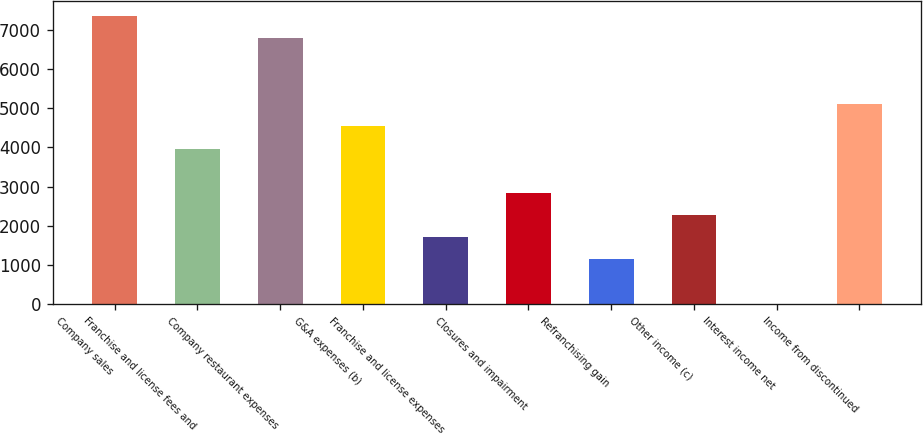Convert chart to OTSL. <chart><loc_0><loc_0><loc_500><loc_500><bar_chart><fcel>Company sales<fcel>Franchise and license fees and<fcel>Company restaurant expenses<fcel>G&A expenses (b)<fcel>Franchise and license expenses<fcel>Closures and impairment<fcel>Refranchising gain<fcel>Other income (c)<fcel>Interest income net<fcel>Income from discontinued<nl><fcel>7364.7<fcel>3969.3<fcel>6798.8<fcel>4535.2<fcel>1705.7<fcel>2837.5<fcel>1139.8<fcel>2271.6<fcel>8<fcel>5101.1<nl></chart> 